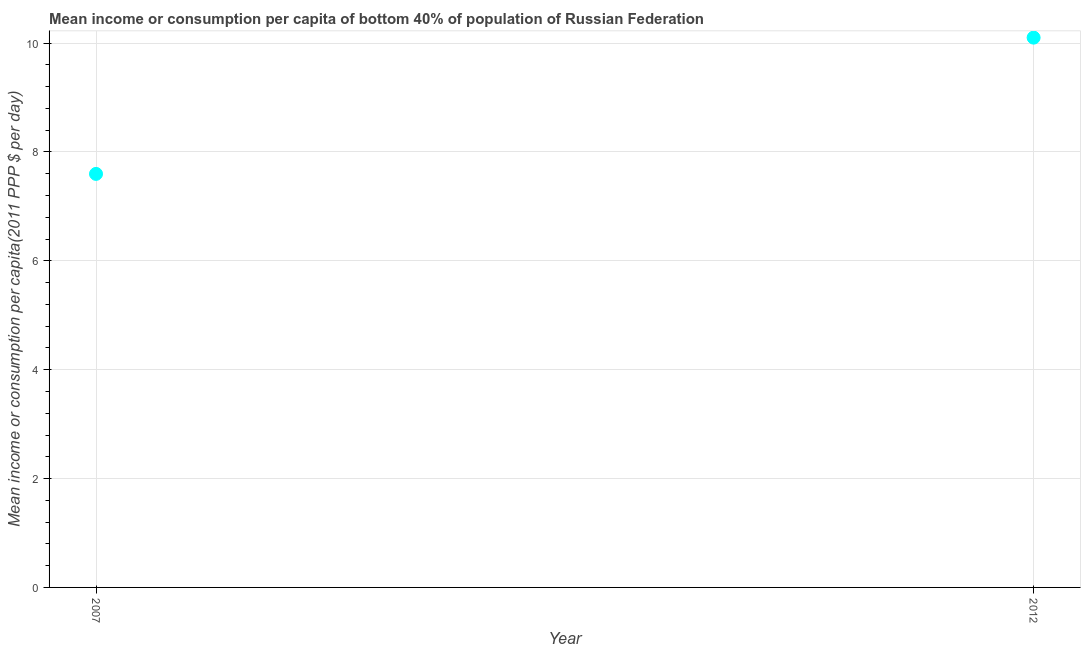What is the mean income or consumption in 2007?
Keep it short and to the point. 7.6. Across all years, what is the maximum mean income or consumption?
Ensure brevity in your answer.  10.1. Across all years, what is the minimum mean income or consumption?
Keep it short and to the point. 7.6. What is the sum of the mean income or consumption?
Your answer should be compact. 17.7. What is the difference between the mean income or consumption in 2007 and 2012?
Your answer should be compact. -2.5. What is the average mean income or consumption per year?
Offer a terse response. 8.85. What is the median mean income or consumption?
Offer a very short reply. 8.85. In how many years, is the mean income or consumption greater than 2 $?
Your answer should be compact. 2. What is the ratio of the mean income or consumption in 2007 to that in 2012?
Keep it short and to the point. 0.75. In how many years, is the mean income or consumption greater than the average mean income or consumption taken over all years?
Offer a terse response. 1. How many dotlines are there?
Offer a very short reply. 1. How many years are there in the graph?
Your answer should be compact. 2. Are the values on the major ticks of Y-axis written in scientific E-notation?
Ensure brevity in your answer.  No. Does the graph contain any zero values?
Keep it short and to the point. No. Does the graph contain grids?
Make the answer very short. Yes. What is the title of the graph?
Give a very brief answer. Mean income or consumption per capita of bottom 40% of population of Russian Federation. What is the label or title of the X-axis?
Offer a terse response. Year. What is the label or title of the Y-axis?
Make the answer very short. Mean income or consumption per capita(2011 PPP $ per day). What is the Mean income or consumption per capita(2011 PPP $ per day) in 2007?
Give a very brief answer. 7.6. What is the Mean income or consumption per capita(2011 PPP $ per day) in 2012?
Provide a succinct answer. 10.1. What is the difference between the Mean income or consumption per capita(2011 PPP $ per day) in 2007 and 2012?
Your answer should be compact. -2.5. What is the ratio of the Mean income or consumption per capita(2011 PPP $ per day) in 2007 to that in 2012?
Provide a succinct answer. 0.75. 